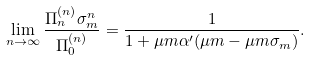<formula> <loc_0><loc_0><loc_500><loc_500>\lim _ { n \to \infty } \frac { \Pi _ { n } ^ { ( n ) } \sigma _ { m } ^ { n } } { \Pi _ { 0 } ^ { ( n ) } } = \frac { 1 } { 1 + \mu m \alpha ^ { \prime } ( \mu m - \mu m \sigma _ { m } ) } .</formula> 